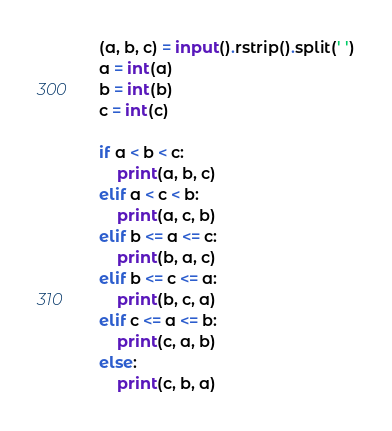<code> <loc_0><loc_0><loc_500><loc_500><_Python_>(a, b, c) = input().rstrip().split(' ')
a = int(a)
b = int(b)
c = int(c)

if a < b < c:
    print(a, b, c)
elif a < c < b:
    print(a, c, b)
elif b <= a <= c:
    print(b, a, c)
elif b <= c <= a:
    print(b, c, a)
elif c <= a <= b:
    print(c, a, b)
else:
    print(c, b, a)</code> 